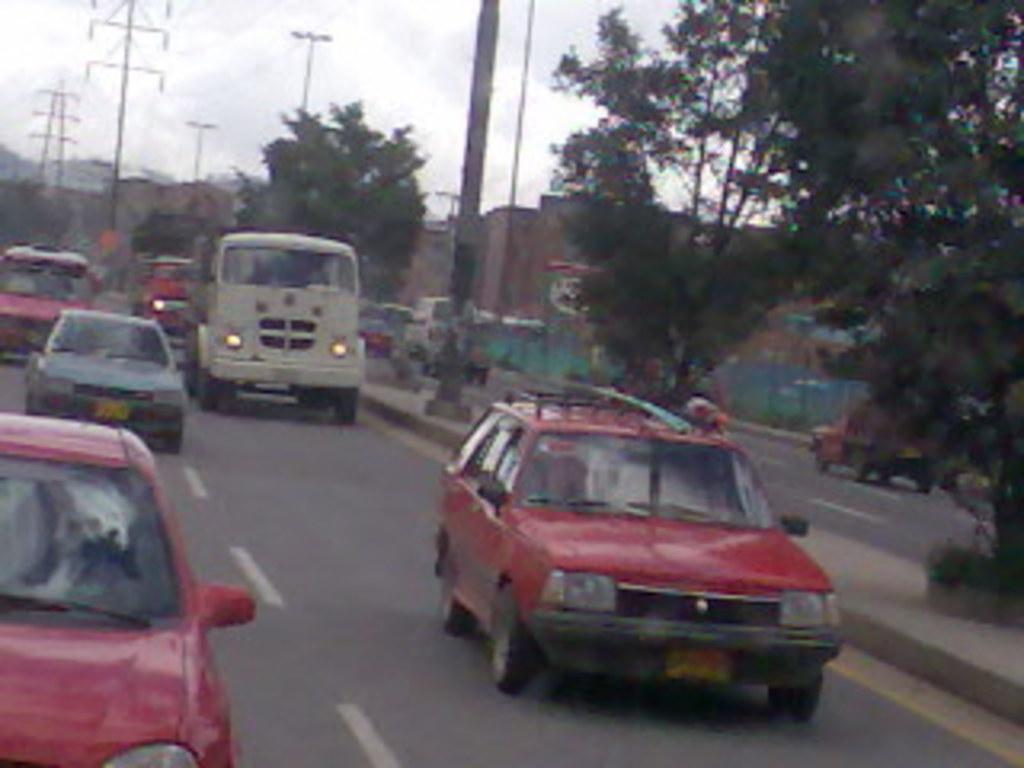What can be seen on the road in the image? There are cars on the road in the image. What type of natural elements are visible in the background of the image? There are trees in the background of the image. What type of man-made structures can be seen in the background of the image? There are towers, lights, and buildings in the background of the image. What part of the natural environment is visible in the image? The sky is visible in the background of the image. How many babies are playing with a jewel in the cemetery in the image? There is no cemetery, babies, or jewel present in the image. 